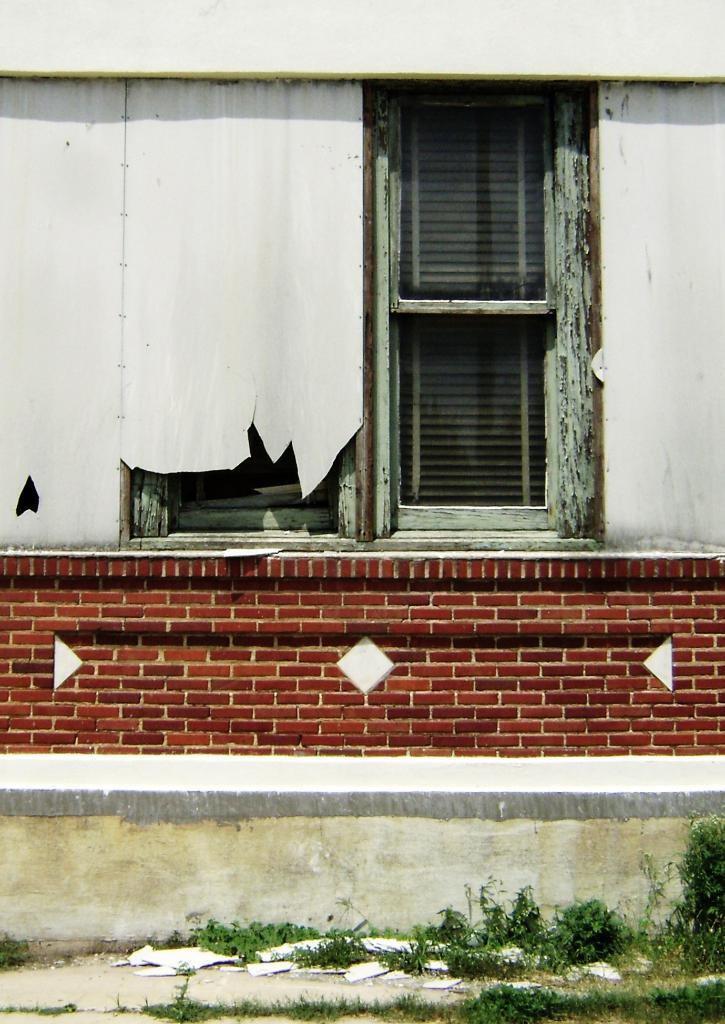What is present at the bottom of the picture? There are plants, grass, and materials at the bottom of the picture. What type of vegetation can be seen at the bottom of the picture? There is grass at the bottom of the picture. What is located in the center of the picture? There is a brick wall in the center of the picture. What is the color of the wall with the window? The wall with the window is painted white. Where is the window located in the picture? The window is at the top of the picture. How does the roof look like in the image? There is no roof present in the image. What type of wind can be seen blowing through the window in the image? There is no wind visible in the image, and the window is not open to show any wind. 